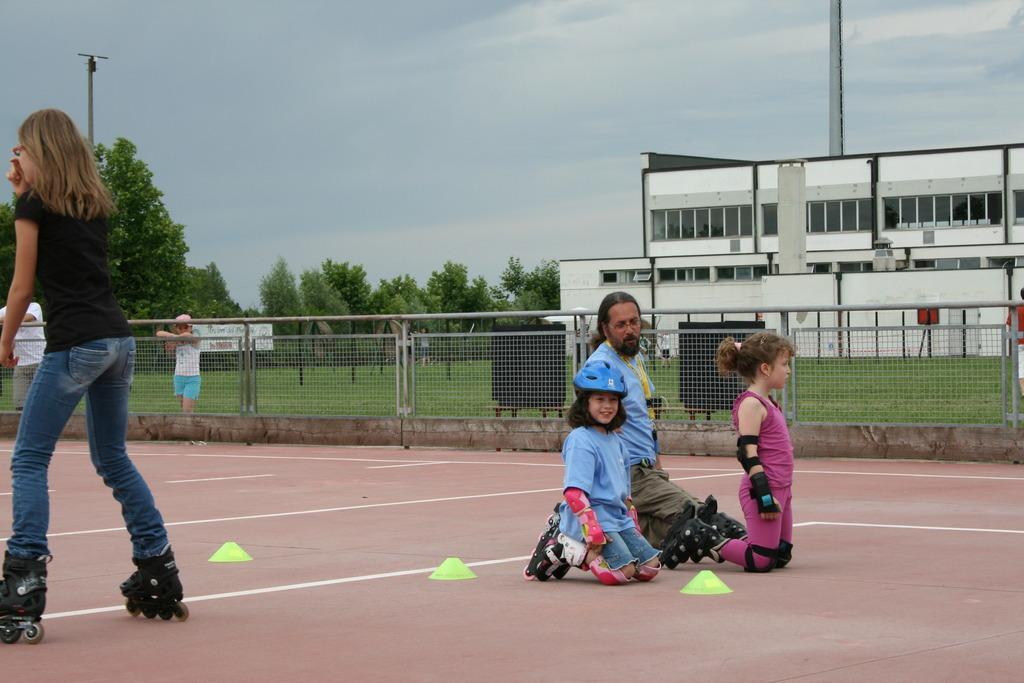Describe this image in one or two sentences. This picture is clicked outside. On the left there is a person wearing black color t-shirt and skating on the ground and we can see the group of persons standing. On the right we can see the group of persons wearing roller skates and kneeling on the ground. In the background there is a sky, trees, mesh, metal rods, buildings and some other objects 